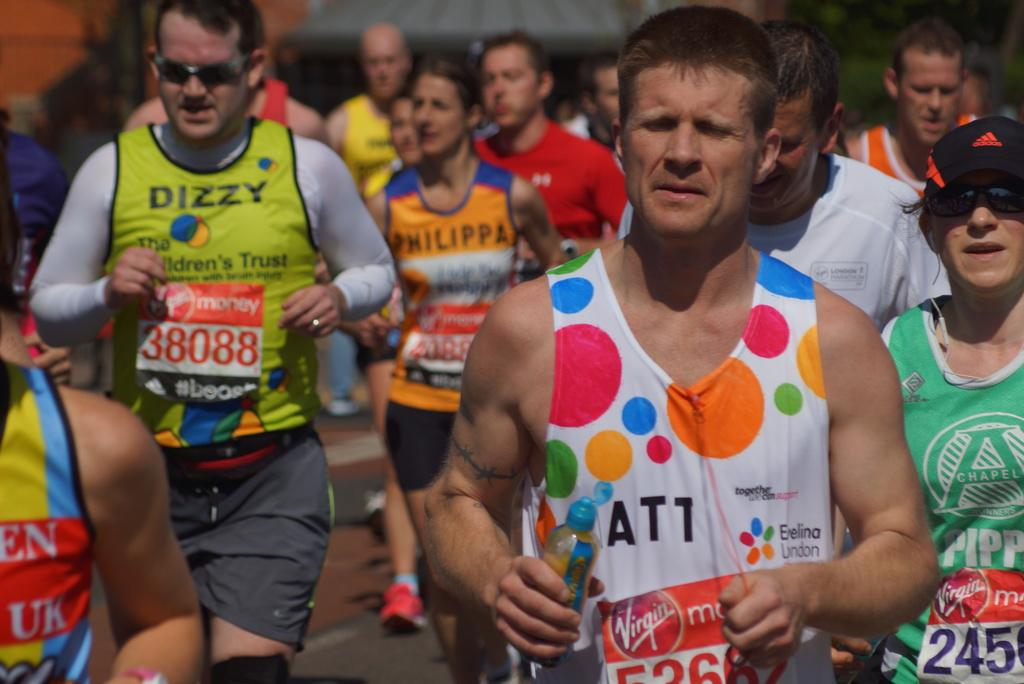How many people are in the image? There are people in the image, but the exact number cannot be determined from the provided facts. What is the person holding in the image? The person is holding a bottle in the image. Can you describe the background of the image? The background of the image is blurred. How many chickens are visible in the image? There are no chickens present in the image. What type of soda is the person drinking from the bottle? The type of soda cannot be determined from the image, as the contents of the bottle are not visible. 